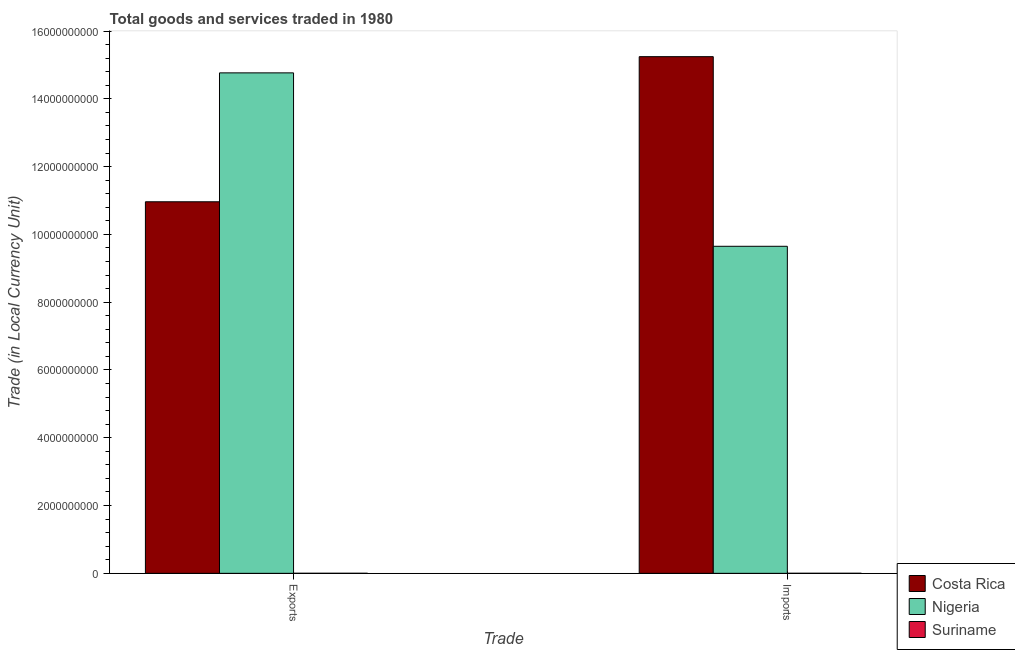How many groups of bars are there?
Make the answer very short. 2. Are the number of bars on each tick of the X-axis equal?
Keep it short and to the point. Yes. How many bars are there on the 1st tick from the right?
Ensure brevity in your answer.  3. What is the label of the 2nd group of bars from the left?
Keep it short and to the point. Imports. What is the export of goods and services in Nigeria?
Provide a short and direct response. 1.48e+1. Across all countries, what is the maximum imports of goods and services?
Offer a very short reply. 1.52e+1. Across all countries, what is the minimum export of goods and services?
Give a very brief answer. 1.09e+06. In which country was the export of goods and services maximum?
Offer a very short reply. Nigeria. In which country was the export of goods and services minimum?
Make the answer very short. Suriname. What is the total imports of goods and services in the graph?
Offer a terse response. 2.49e+1. What is the difference between the export of goods and services in Nigeria and that in Costa Rica?
Your answer should be very brief. 3.80e+09. What is the difference between the export of goods and services in Nigeria and the imports of goods and services in Suriname?
Ensure brevity in your answer.  1.48e+1. What is the average imports of goods and services per country?
Offer a very short reply. 8.30e+09. What is the difference between the imports of goods and services and export of goods and services in Costa Rica?
Keep it short and to the point. 4.28e+09. In how many countries, is the export of goods and services greater than 8000000000 LCU?
Your answer should be very brief. 2. What is the ratio of the imports of goods and services in Costa Rica to that in Suriname?
Your answer should be very brief. 1.29e+04. In how many countries, is the imports of goods and services greater than the average imports of goods and services taken over all countries?
Provide a short and direct response. 2. What does the 2nd bar from the left in Imports represents?
Offer a very short reply. Nigeria. What does the 2nd bar from the right in Exports represents?
Offer a very short reply. Nigeria. How many bars are there?
Offer a very short reply. 6. Are the values on the major ticks of Y-axis written in scientific E-notation?
Keep it short and to the point. No. Does the graph contain grids?
Provide a succinct answer. No. Where does the legend appear in the graph?
Your answer should be compact. Bottom right. How many legend labels are there?
Keep it short and to the point. 3. What is the title of the graph?
Offer a terse response. Total goods and services traded in 1980. Does "Afghanistan" appear as one of the legend labels in the graph?
Your answer should be very brief. No. What is the label or title of the X-axis?
Give a very brief answer. Trade. What is the label or title of the Y-axis?
Ensure brevity in your answer.  Trade (in Local Currency Unit). What is the Trade (in Local Currency Unit) of Costa Rica in Exports?
Provide a succinct answer. 1.10e+1. What is the Trade (in Local Currency Unit) in Nigeria in Exports?
Make the answer very short. 1.48e+1. What is the Trade (in Local Currency Unit) of Suriname in Exports?
Keep it short and to the point. 1.09e+06. What is the Trade (in Local Currency Unit) in Costa Rica in Imports?
Your response must be concise. 1.52e+1. What is the Trade (in Local Currency Unit) of Nigeria in Imports?
Your answer should be compact. 9.65e+09. What is the Trade (in Local Currency Unit) of Suriname in Imports?
Provide a short and direct response. 1.18e+06. Across all Trade, what is the maximum Trade (in Local Currency Unit) in Costa Rica?
Your answer should be compact. 1.52e+1. Across all Trade, what is the maximum Trade (in Local Currency Unit) in Nigeria?
Your response must be concise. 1.48e+1. Across all Trade, what is the maximum Trade (in Local Currency Unit) in Suriname?
Your answer should be compact. 1.18e+06. Across all Trade, what is the minimum Trade (in Local Currency Unit) of Costa Rica?
Offer a very short reply. 1.10e+1. Across all Trade, what is the minimum Trade (in Local Currency Unit) in Nigeria?
Make the answer very short. 9.65e+09. Across all Trade, what is the minimum Trade (in Local Currency Unit) in Suriname?
Provide a short and direct response. 1.09e+06. What is the total Trade (in Local Currency Unit) of Costa Rica in the graph?
Your answer should be compact. 2.62e+1. What is the total Trade (in Local Currency Unit) in Nigeria in the graph?
Your answer should be compact. 2.44e+1. What is the total Trade (in Local Currency Unit) of Suriname in the graph?
Provide a short and direct response. 2.27e+06. What is the difference between the Trade (in Local Currency Unit) in Costa Rica in Exports and that in Imports?
Give a very brief answer. -4.28e+09. What is the difference between the Trade (in Local Currency Unit) in Nigeria in Exports and that in Imports?
Your response must be concise. 5.12e+09. What is the difference between the Trade (in Local Currency Unit) of Suriname in Exports and that in Imports?
Make the answer very short. -8.60e+04. What is the difference between the Trade (in Local Currency Unit) of Costa Rica in Exports and the Trade (in Local Currency Unit) of Nigeria in Imports?
Provide a succinct answer. 1.31e+09. What is the difference between the Trade (in Local Currency Unit) of Costa Rica in Exports and the Trade (in Local Currency Unit) of Suriname in Imports?
Provide a succinct answer. 1.10e+1. What is the difference between the Trade (in Local Currency Unit) of Nigeria in Exports and the Trade (in Local Currency Unit) of Suriname in Imports?
Keep it short and to the point. 1.48e+1. What is the average Trade (in Local Currency Unit) of Costa Rica per Trade?
Your response must be concise. 1.31e+1. What is the average Trade (in Local Currency Unit) of Nigeria per Trade?
Give a very brief answer. 1.22e+1. What is the average Trade (in Local Currency Unit) of Suriname per Trade?
Make the answer very short. 1.14e+06. What is the difference between the Trade (in Local Currency Unit) of Costa Rica and Trade (in Local Currency Unit) of Nigeria in Exports?
Your answer should be very brief. -3.80e+09. What is the difference between the Trade (in Local Currency Unit) of Costa Rica and Trade (in Local Currency Unit) of Suriname in Exports?
Your response must be concise. 1.10e+1. What is the difference between the Trade (in Local Currency Unit) in Nigeria and Trade (in Local Currency Unit) in Suriname in Exports?
Make the answer very short. 1.48e+1. What is the difference between the Trade (in Local Currency Unit) in Costa Rica and Trade (in Local Currency Unit) in Nigeria in Imports?
Offer a terse response. 5.60e+09. What is the difference between the Trade (in Local Currency Unit) of Costa Rica and Trade (in Local Currency Unit) of Suriname in Imports?
Provide a short and direct response. 1.52e+1. What is the difference between the Trade (in Local Currency Unit) of Nigeria and Trade (in Local Currency Unit) of Suriname in Imports?
Your answer should be compact. 9.65e+09. What is the ratio of the Trade (in Local Currency Unit) of Costa Rica in Exports to that in Imports?
Your answer should be very brief. 0.72. What is the ratio of the Trade (in Local Currency Unit) in Nigeria in Exports to that in Imports?
Give a very brief answer. 1.53. What is the ratio of the Trade (in Local Currency Unit) in Suriname in Exports to that in Imports?
Keep it short and to the point. 0.93. What is the difference between the highest and the second highest Trade (in Local Currency Unit) in Costa Rica?
Offer a terse response. 4.28e+09. What is the difference between the highest and the second highest Trade (in Local Currency Unit) of Nigeria?
Your answer should be compact. 5.12e+09. What is the difference between the highest and the second highest Trade (in Local Currency Unit) in Suriname?
Offer a terse response. 8.60e+04. What is the difference between the highest and the lowest Trade (in Local Currency Unit) in Costa Rica?
Offer a very short reply. 4.28e+09. What is the difference between the highest and the lowest Trade (in Local Currency Unit) in Nigeria?
Keep it short and to the point. 5.12e+09. What is the difference between the highest and the lowest Trade (in Local Currency Unit) of Suriname?
Offer a very short reply. 8.60e+04. 